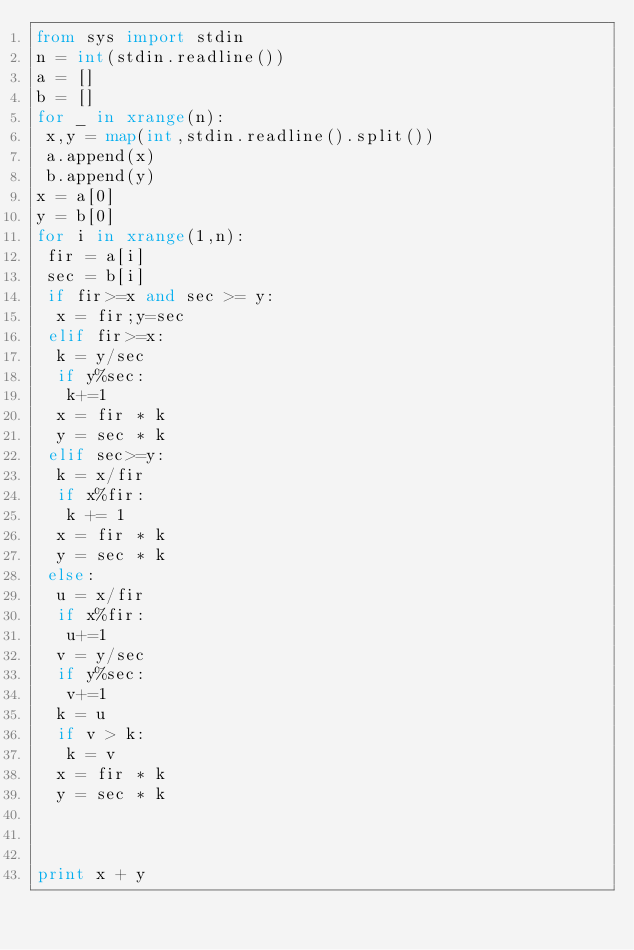<code> <loc_0><loc_0><loc_500><loc_500><_Python_>from sys import stdin
n = int(stdin.readline())
a = []
b = []
for _ in xrange(n):
 x,y = map(int,stdin.readline().split())
 a.append(x)
 b.append(y)
x = a[0]
y = b[0]
for i in xrange(1,n):
 fir = a[i]
 sec = b[i]
 if fir>=x and sec >= y:
  x = fir;y=sec
 elif fir>=x:
  k = y/sec
  if y%sec:
   k+=1
  x = fir * k
  y = sec * k
 elif sec>=y:
  k = x/fir
  if x%fir:
   k += 1
  x = fir * k
  y = sec * k
 else:
  u = x/fir
  if x%fir:
   u+=1
  v = y/sec
  if y%sec:
   v+=1
  k = u
  if v > k:
   k = v
  x = fir * k
  y = sec * k



print x + y</code> 